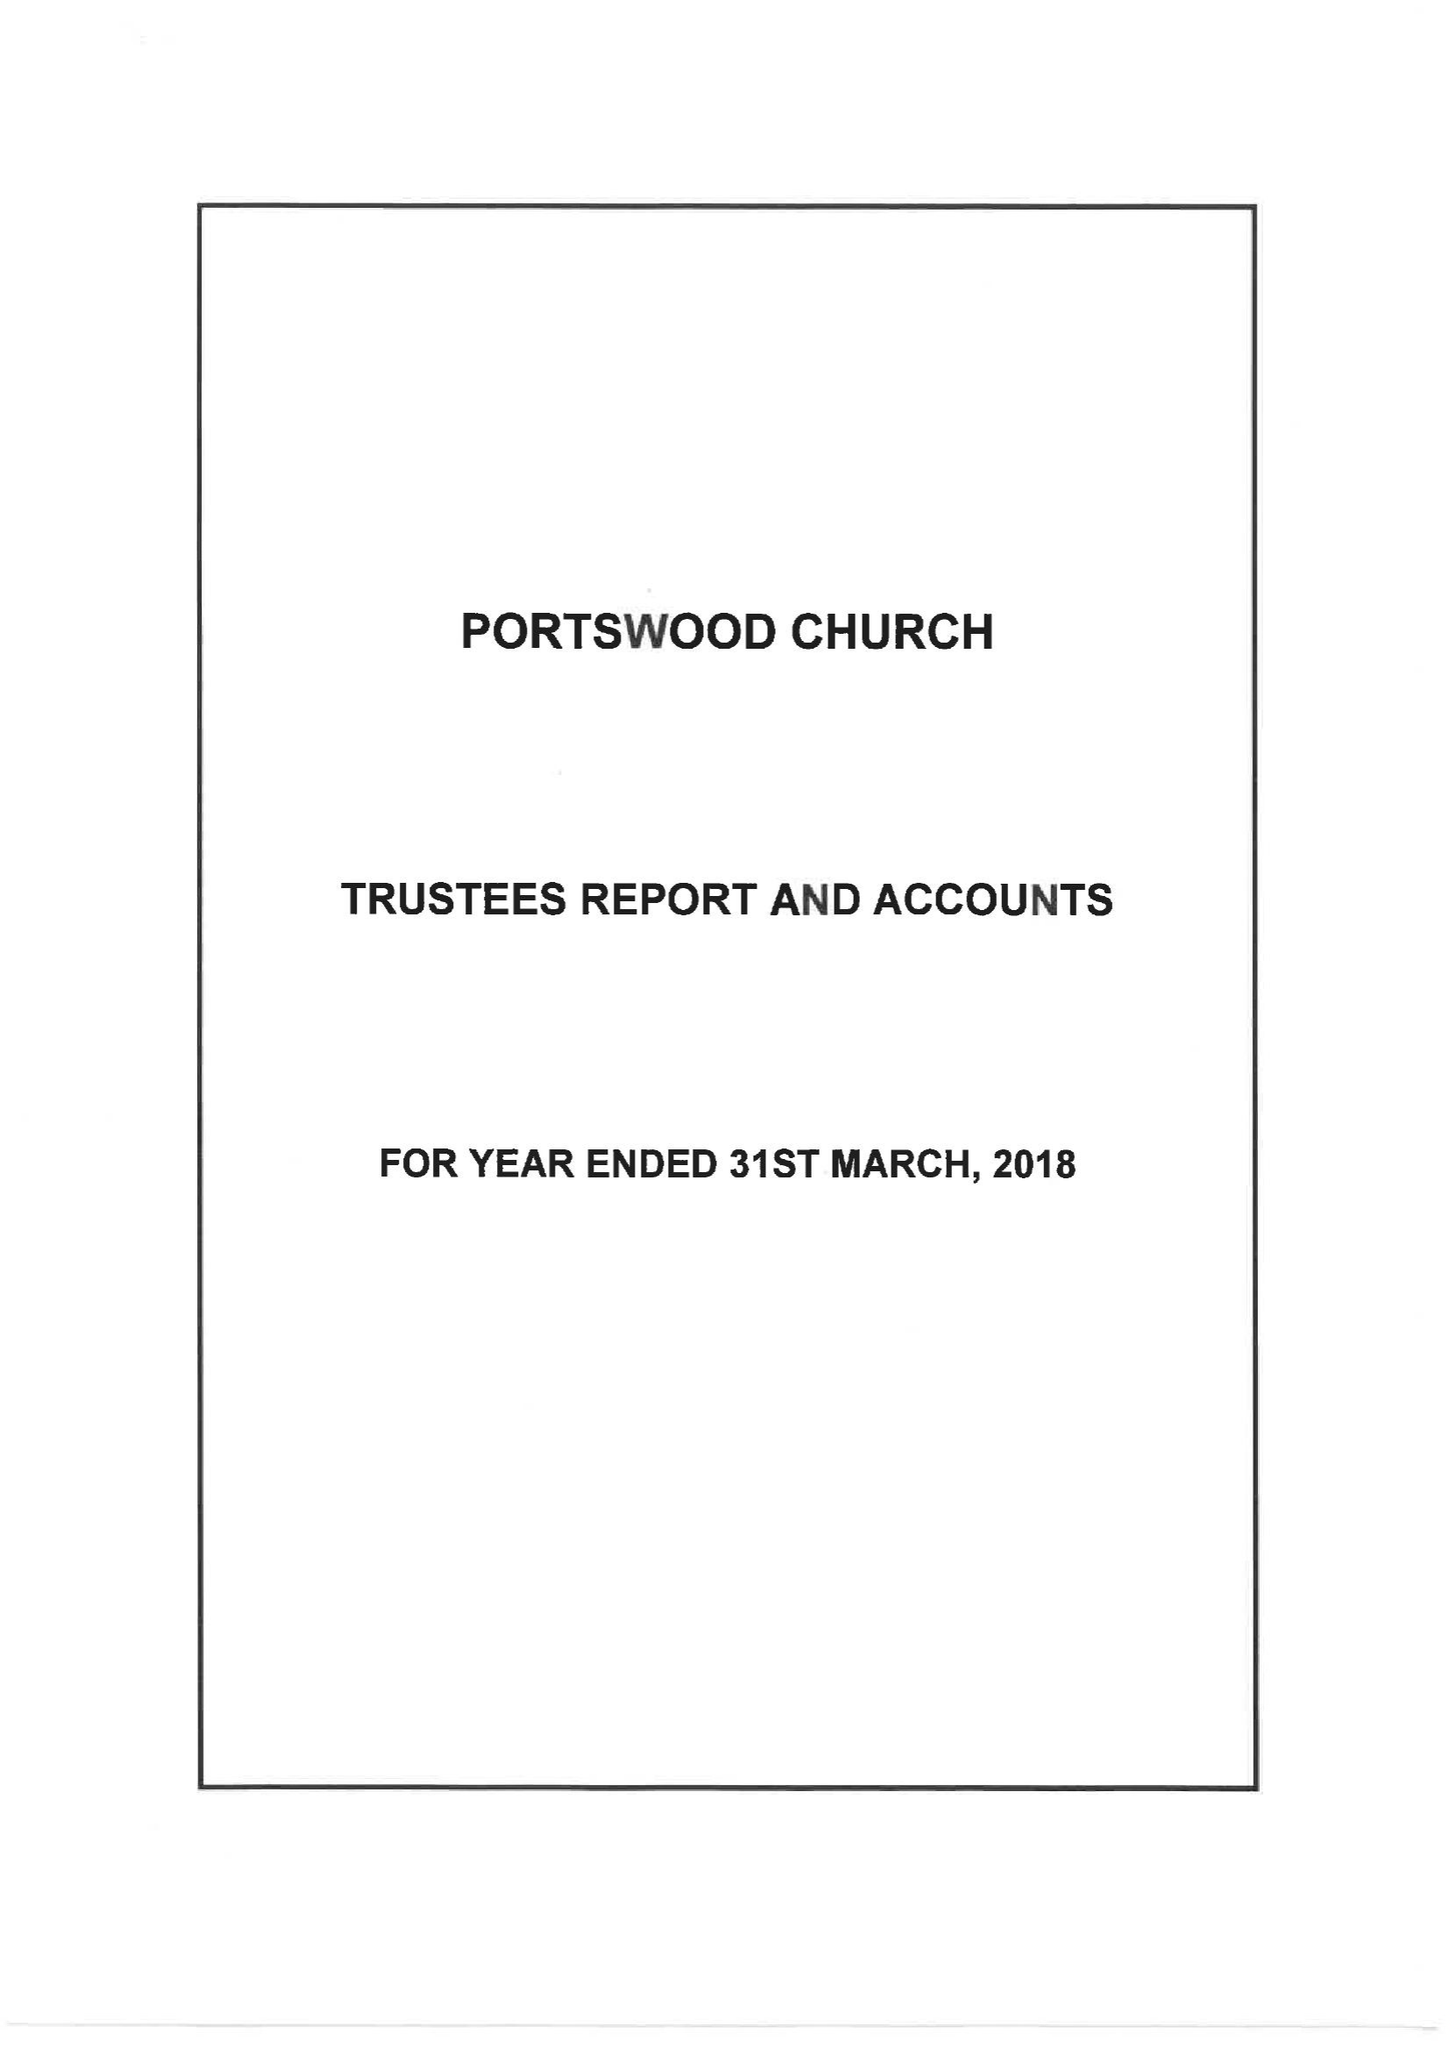What is the value for the charity_number?
Answer the question using a single word or phrase. 248769 